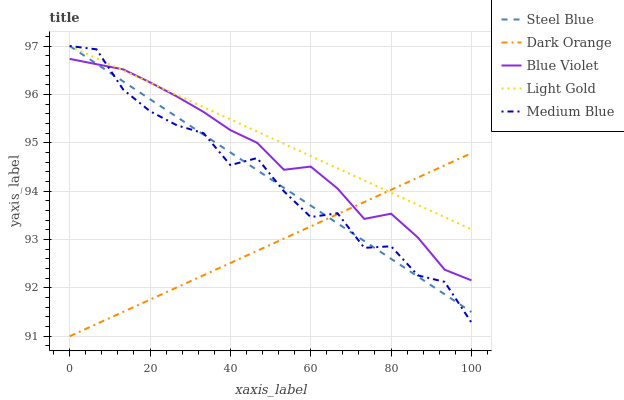Does Dark Orange have the minimum area under the curve?
Answer yes or no. Yes. Does Light Gold have the maximum area under the curve?
Answer yes or no. Yes. Does Light Gold have the minimum area under the curve?
Answer yes or no. No. Does Dark Orange have the maximum area under the curve?
Answer yes or no. No. Is Steel Blue the smoothest?
Answer yes or no. Yes. Is Medium Blue the roughest?
Answer yes or no. Yes. Is Dark Orange the smoothest?
Answer yes or no. No. Is Dark Orange the roughest?
Answer yes or no. No. Does Dark Orange have the lowest value?
Answer yes or no. Yes. Does Light Gold have the lowest value?
Answer yes or no. No. Does Steel Blue have the highest value?
Answer yes or no. Yes. Does Dark Orange have the highest value?
Answer yes or no. No. Does Light Gold intersect Dark Orange?
Answer yes or no. Yes. Is Light Gold less than Dark Orange?
Answer yes or no. No. Is Light Gold greater than Dark Orange?
Answer yes or no. No. 